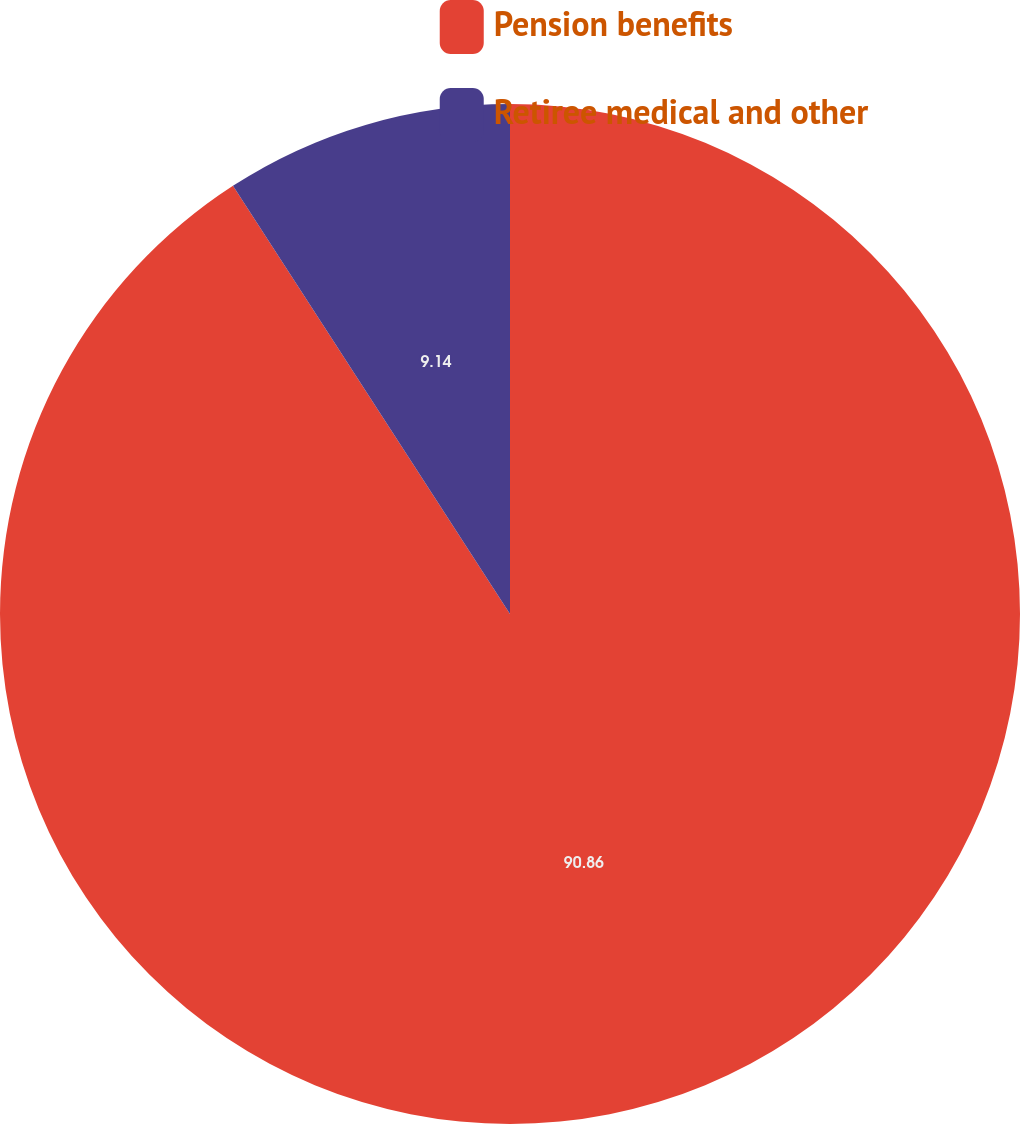Convert chart. <chart><loc_0><loc_0><loc_500><loc_500><pie_chart><fcel>Pension benefits<fcel>Retiree medical and other<nl><fcel>90.86%<fcel>9.14%<nl></chart> 